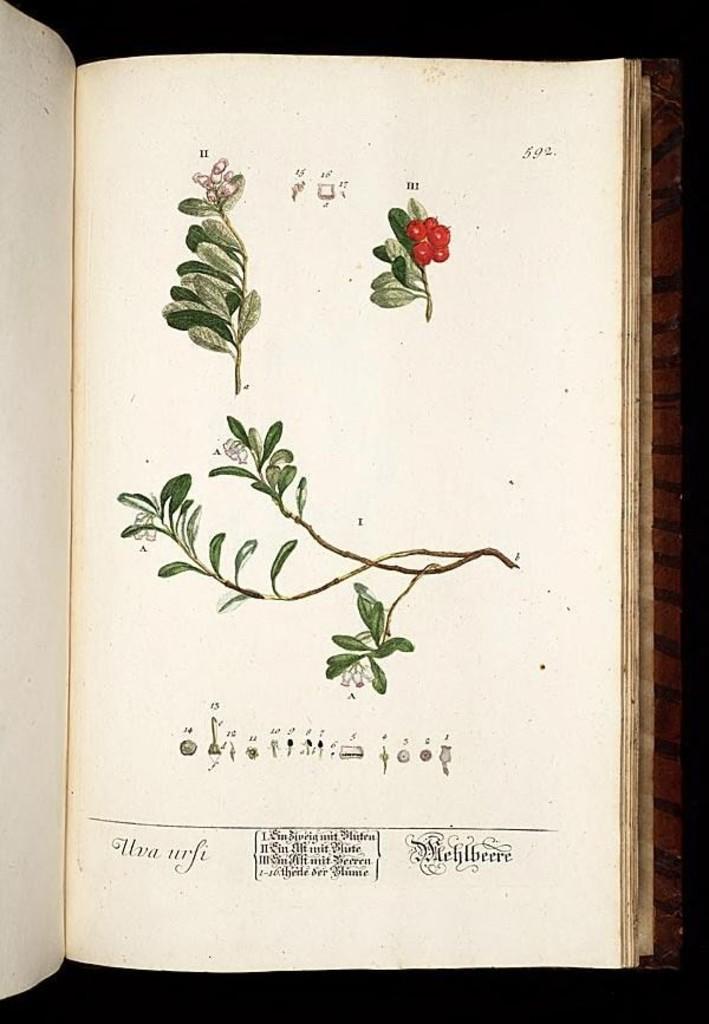What is the main subject in the center of the image? There is a book in the center of the image. What type of content is featured in the book? The book contains drawings of leaves and fruits. Is there any text in the book? Yes, there is writing in the book. What type of ball is being used to hold the flag in the image? There is no ball or flag present in the image; it only features a book with drawings of leaves and fruits and writing. 